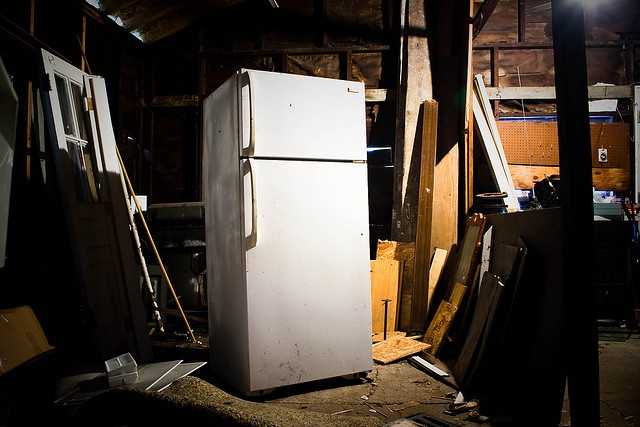Describe the objects in this image and their specific colors. I can see a refrigerator in black, white, gray, and darkgray tones in this image. 